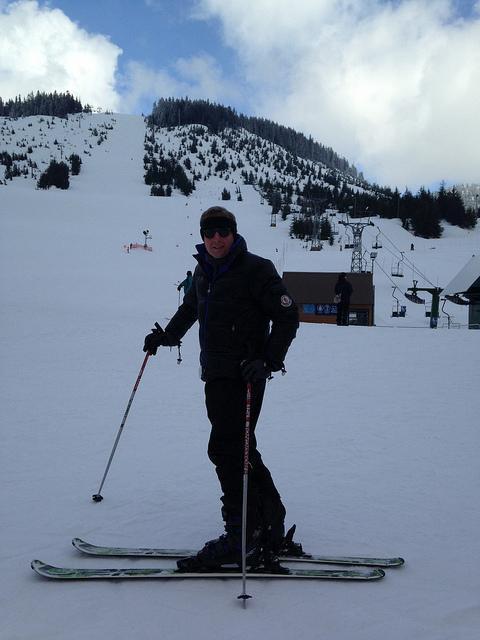How many ski are there?
Give a very brief answer. 1. 